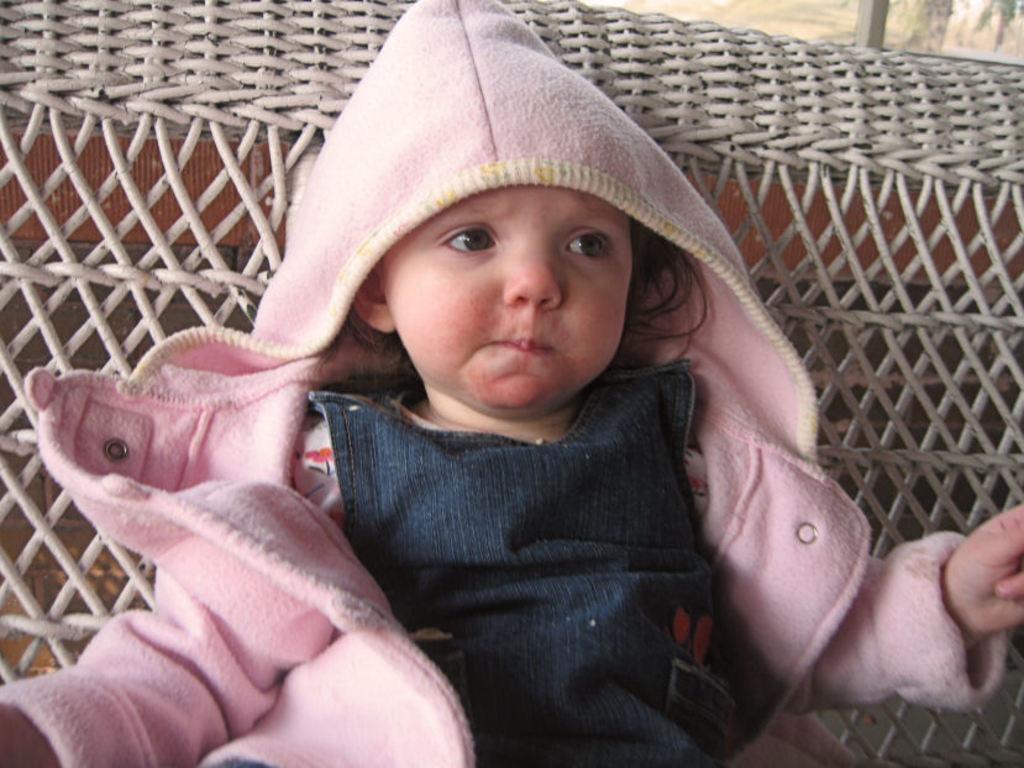What is the main subject of the image? The main subject of the image is a kid. Where is the kid located in the image? The kid is sitting on a sofa in the image. What is the kid wearing in the image? The kid is wearing a pink sweater in the image. What type of snake can be seen slithering on the sofa next to the kid in the image? There is no snake present in the image; the kid is sitting on the sofa alone. 